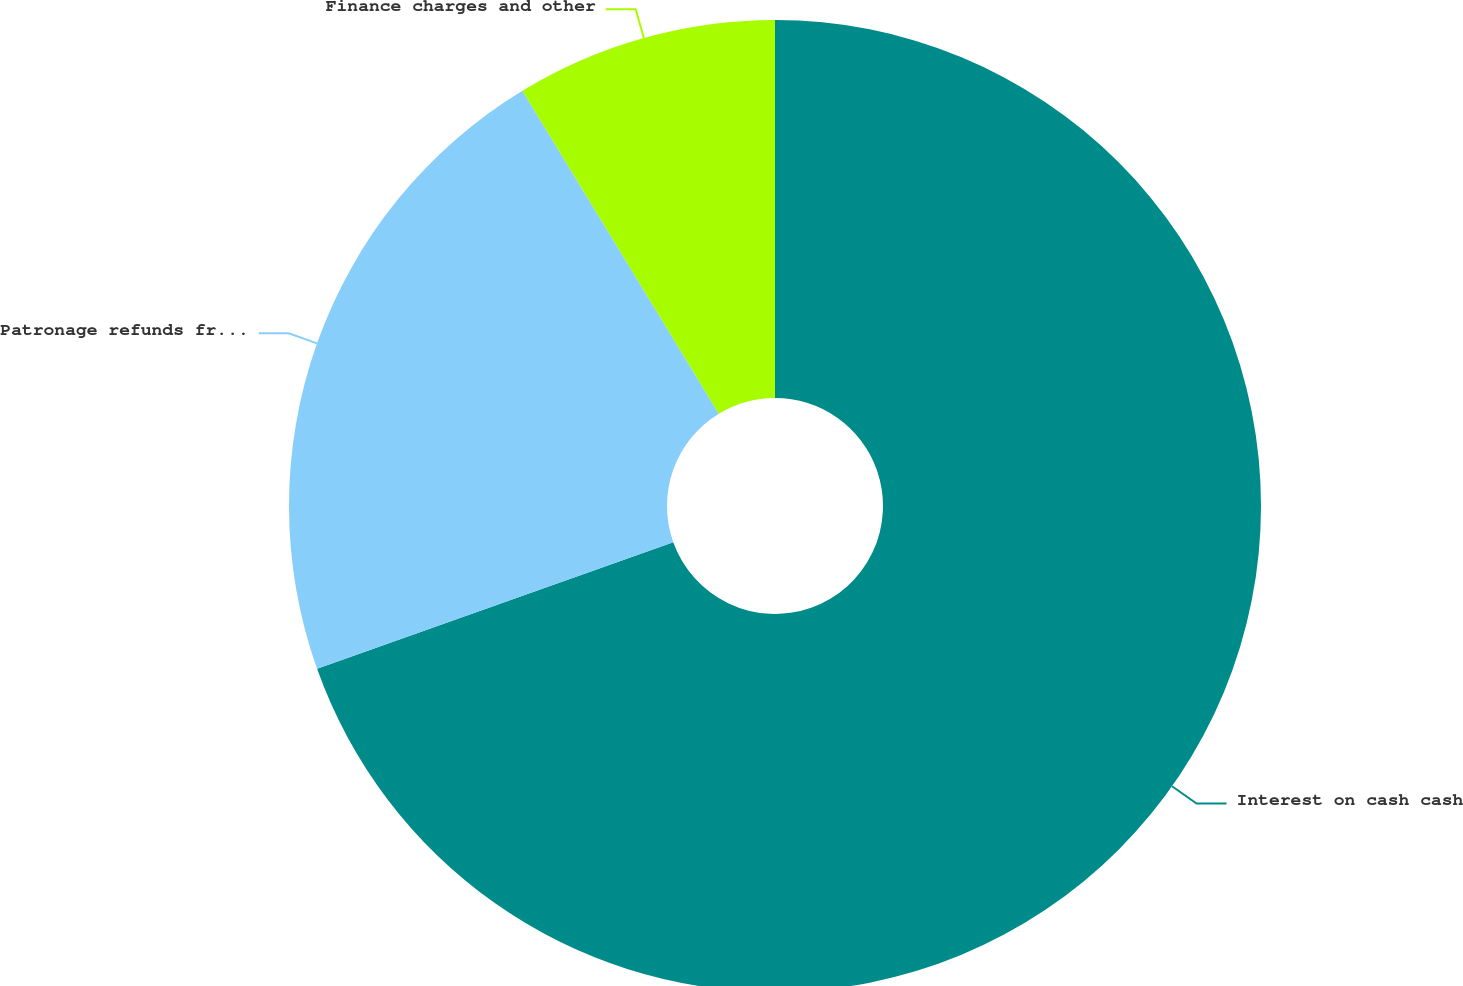Convert chart to OTSL. <chart><loc_0><loc_0><loc_500><loc_500><pie_chart><fcel>Interest on cash cash<fcel>Patronage refunds from CoBank<fcel>Finance charges and other<nl><fcel>69.57%<fcel>21.74%<fcel>8.7%<nl></chart> 